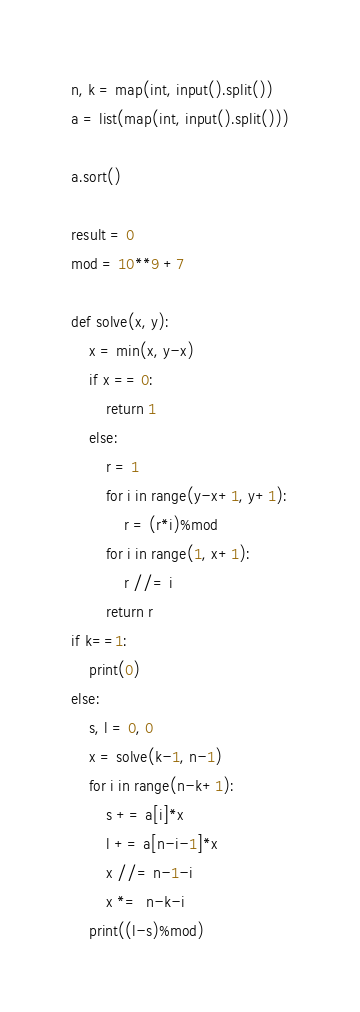Convert code to text. <code><loc_0><loc_0><loc_500><loc_500><_Python_>n, k = map(int, input().split())
a = list(map(int, input().split()))

a.sort()

result = 0
mod = 10**9 +7

def solve(x, y):
    x = min(x, y-x)
    if x == 0:
        return 1
    else:
        r = 1
        for i in range(y-x+1, y+1):
            r = (r*i)%mod
        for i in range(1, x+1):
            r //= i
        return r
if k==1:
    print(0)
else:
    s, l = 0, 0
    x = solve(k-1, n-1)
    for i in range(n-k+1):
        s += a[i]*x
        l += a[n-i-1]*x
        x //= n-1-i
        x *=  n-k-i
    print((l-s)%mod)</code> 